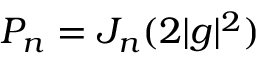Convert formula to latex. <formula><loc_0><loc_0><loc_500><loc_500>P _ { n } = J _ { n } ( 2 | g | ^ { 2 } )</formula> 